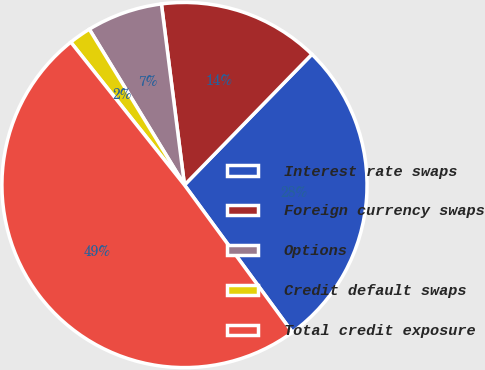Convert chart. <chart><loc_0><loc_0><loc_500><loc_500><pie_chart><fcel>Interest rate swaps<fcel>Foreign currency swaps<fcel>Options<fcel>Credit default swaps<fcel>Total credit exposure<nl><fcel>27.64%<fcel>14.31%<fcel>6.71%<fcel>1.97%<fcel>49.36%<nl></chart> 